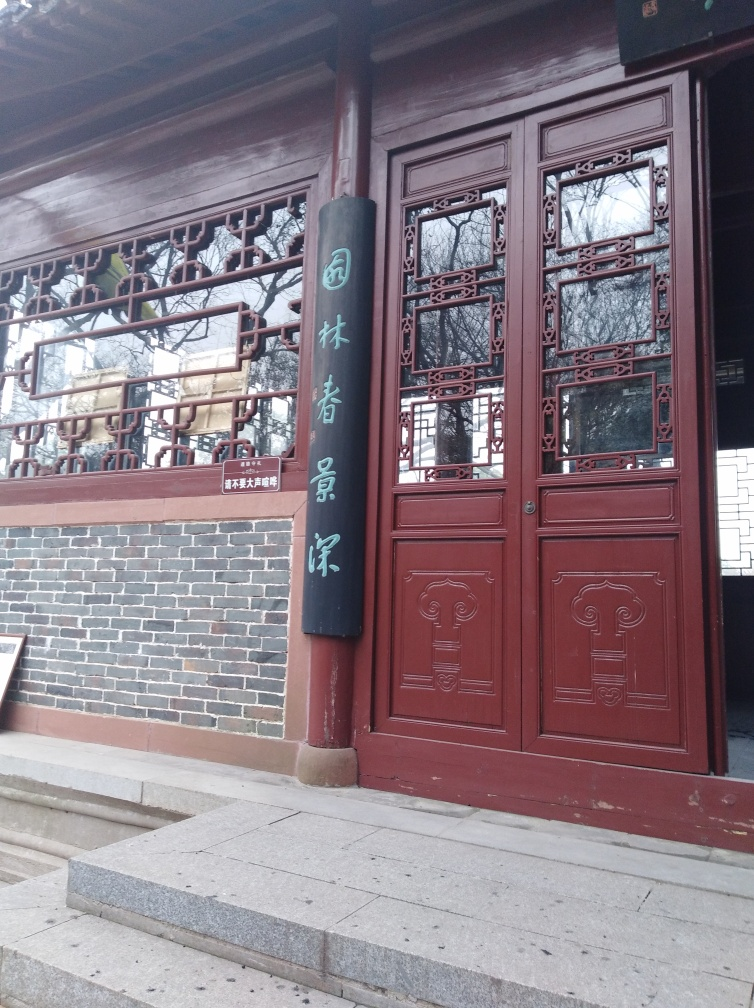What type of building is shown in the image? The image depicts a traditional Asian-style building, likely a temple or historical residence, as indicated by the characteristic wooden doors and ornamental window frames. 